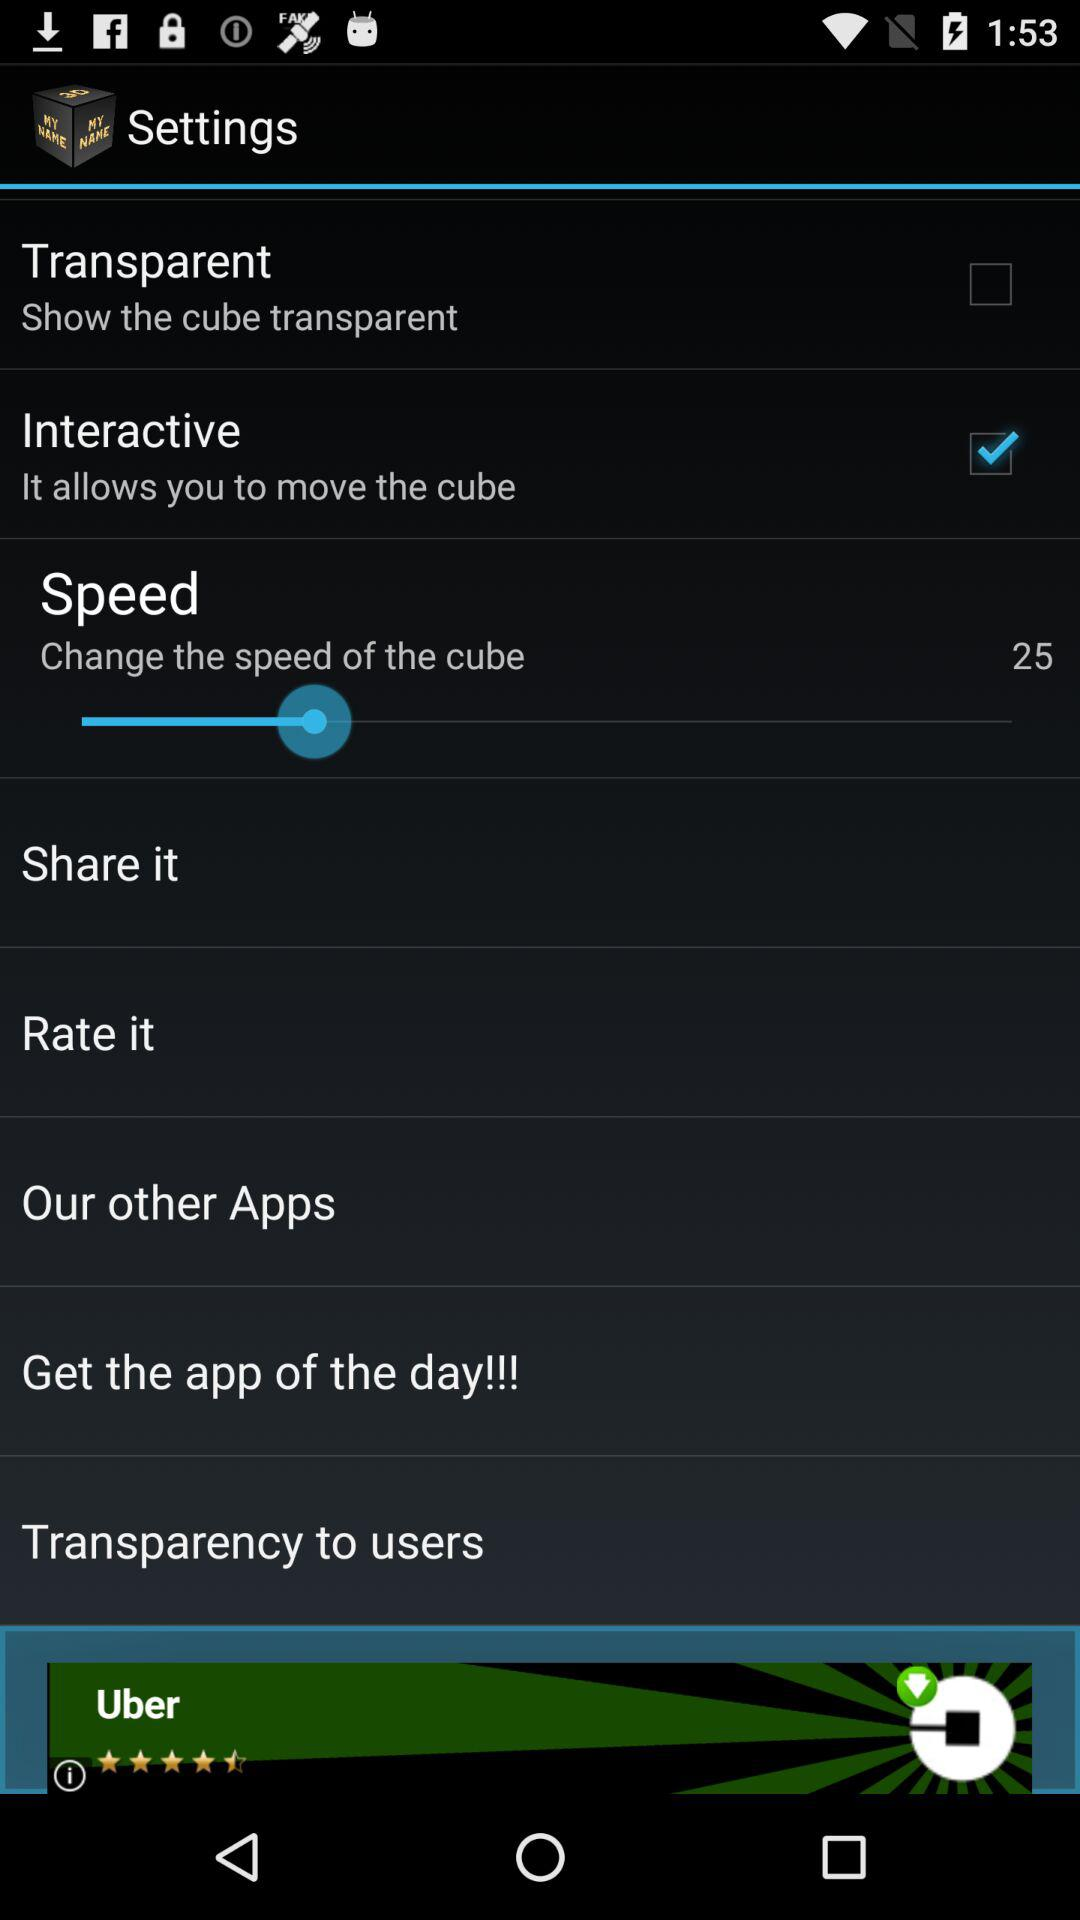What is the speed of the cube? The speed of the cube is 25. 